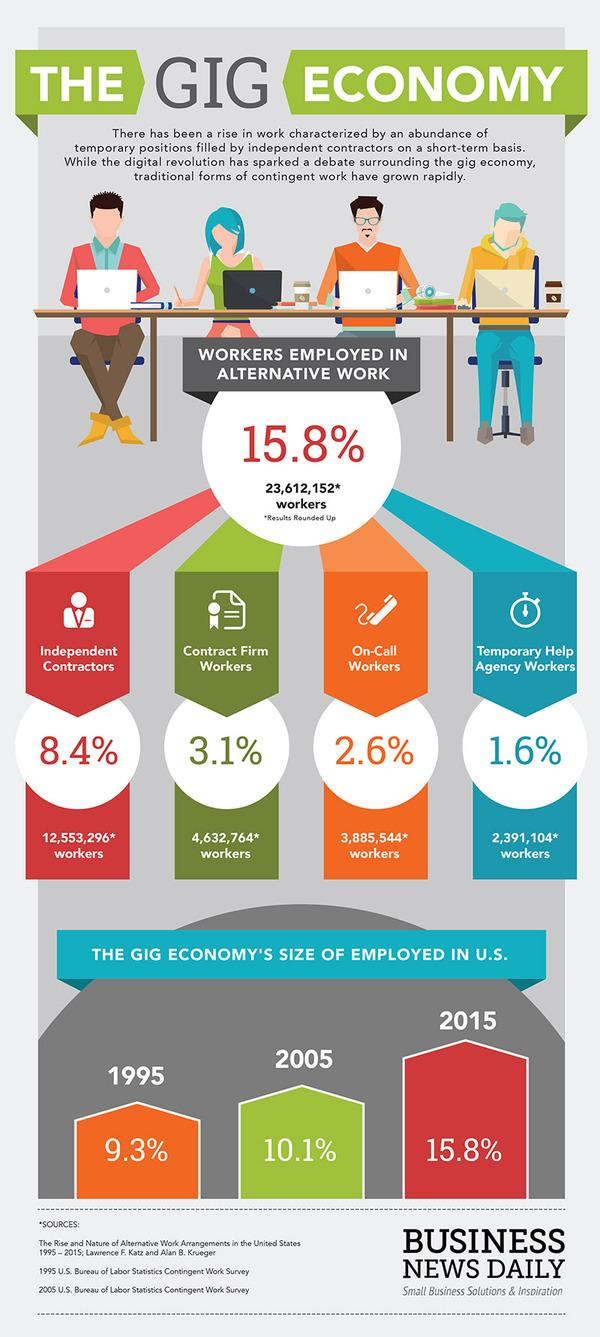Highlight a few significant elements in this photo. The gig economy is dominated by independent contractors, who are a type of worker that has the freedom to work for multiple clients and set their own schedules and rates. According to the given number, there are approximately 12,553,296 independent contractors. There are approximately 388,5544 on-call workers. According to the given number, there are approximately 46,327,640 contract form workers. 